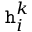Convert formula to latex. <formula><loc_0><loc_0><loc_500><loc_500>h _ { i } ^ { k }</formula> 